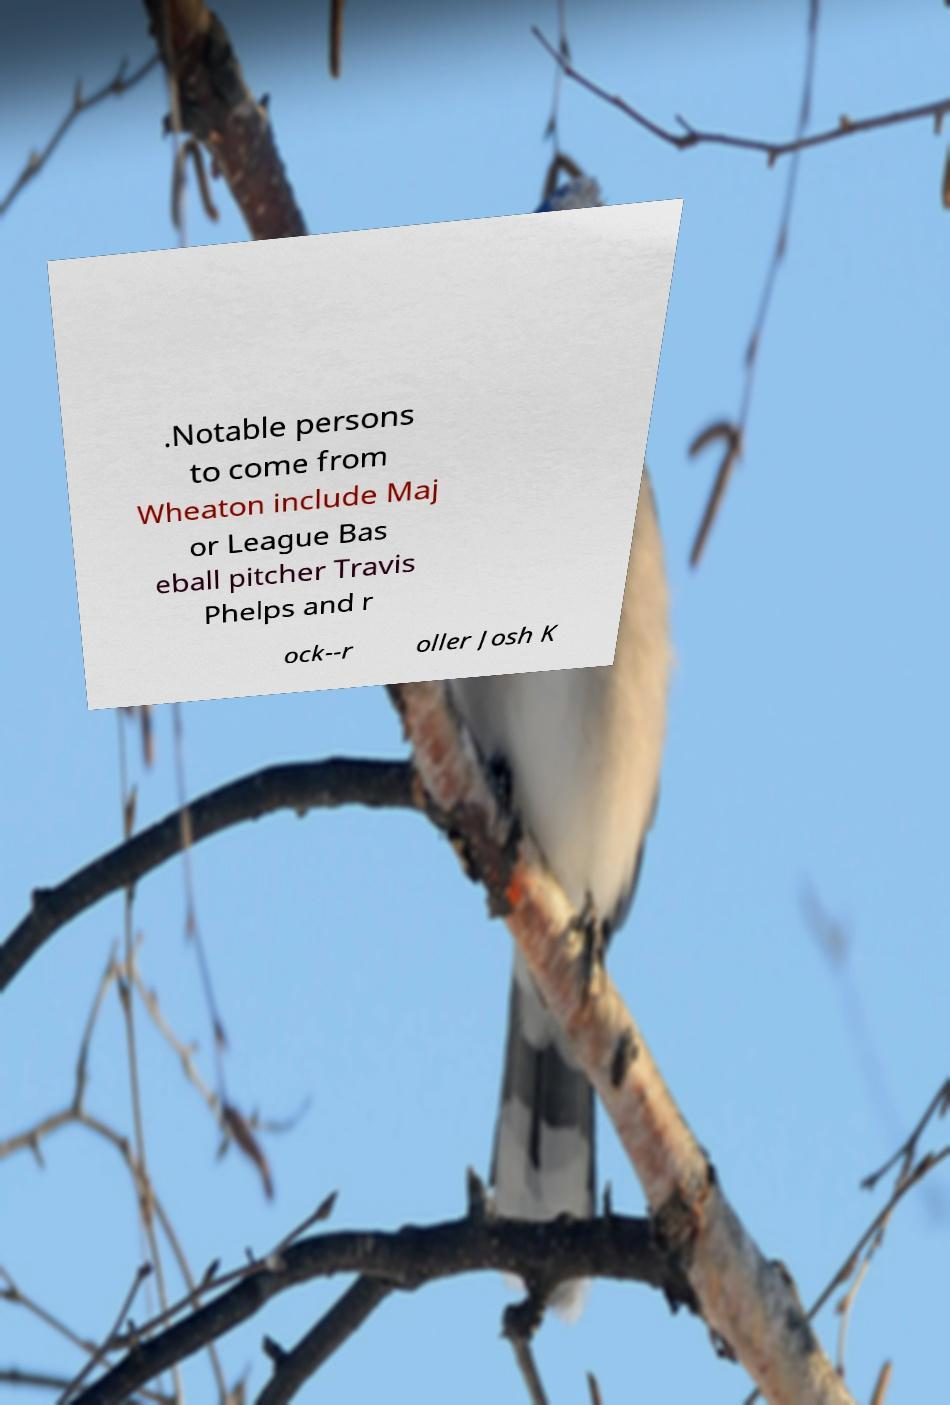Please identify and transcribe the text found in this image. .Notable persons to come from Wheaton include Maj or League Bas eball pitcher Travis Phelps and r ock--r oller Josh K 